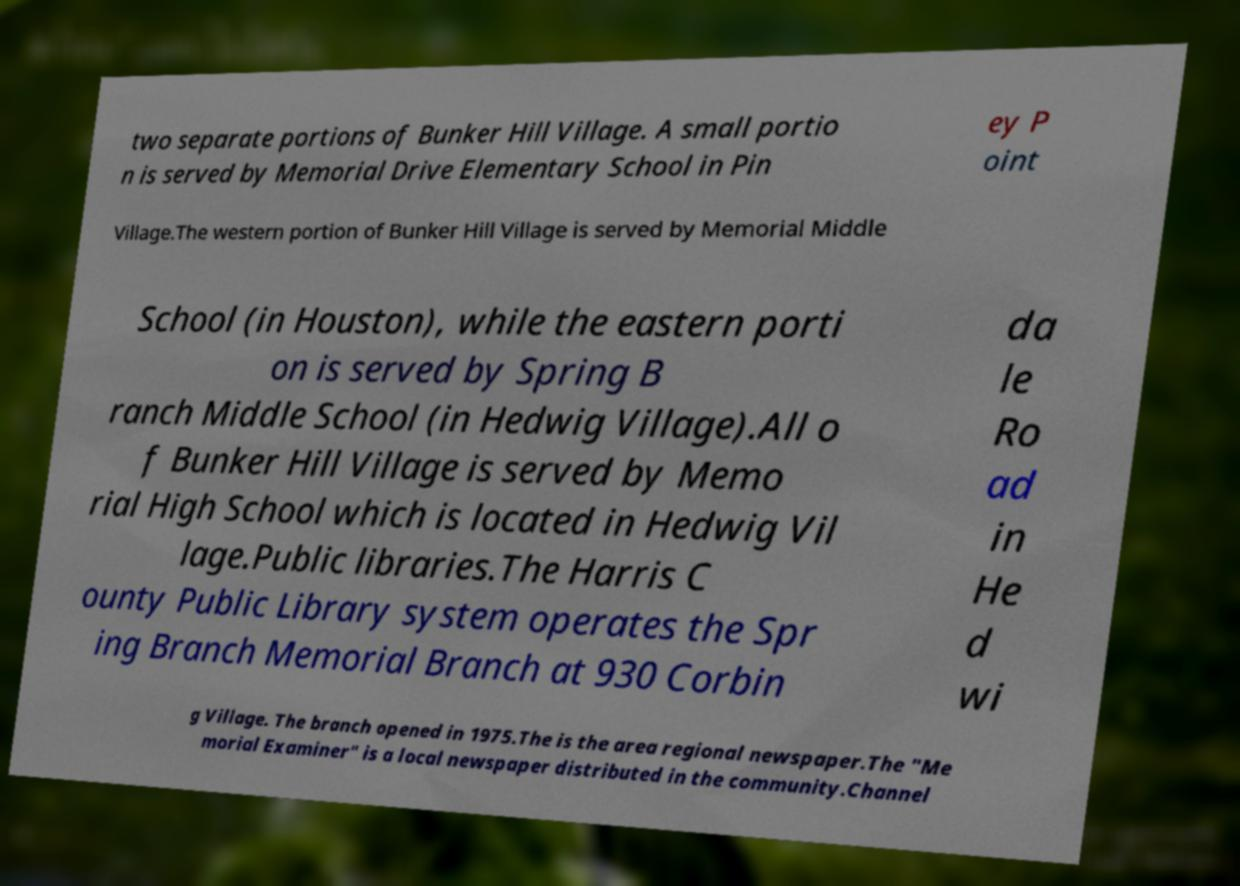Could you extract and type out the text from this image? two separate portions of Bunker Hill Village. A small portio n is served by Memorial Drive Elementary School in Pin ey P oint Village.The western portion of Bunker Hill Village is served by Memorial Middle School (in Houston), while the eastern porti on is served by Spring B ranch Middle School (in Hedwig Village).All o f Bunker Hill Village is served by Memo rial High School which is located in Hedwig Vil lage.Public libraries.The Harris C ounty Public Library system operates the Spr ing Branch Memorial Branch at 930 Corbin da le Ro ad in He d wi g Village. The branch opened in 1975.The is the area regional newspaper.The "Me morial Examiner" is a local newspaper distributed in the community.Channel 